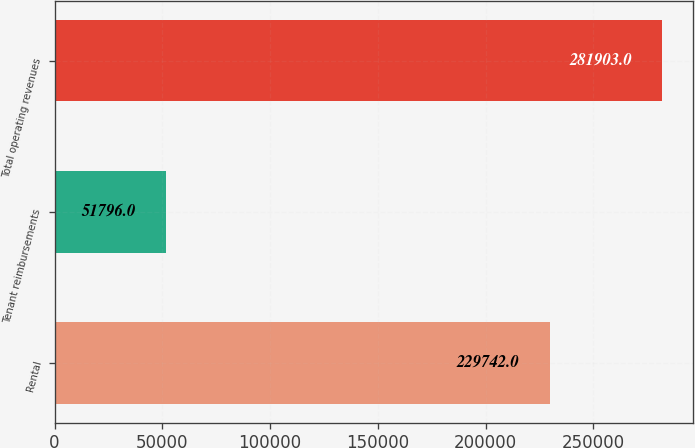Convert chart. <chart><loc_0><loc_0><loc_500><loc_500><bar_chart><fcel>Rental<fcel>Tenant reimbursements<fcel>Total operating revenues<nl><fcel>229742<fcel>51796<fcel>281903<nl></chart> 